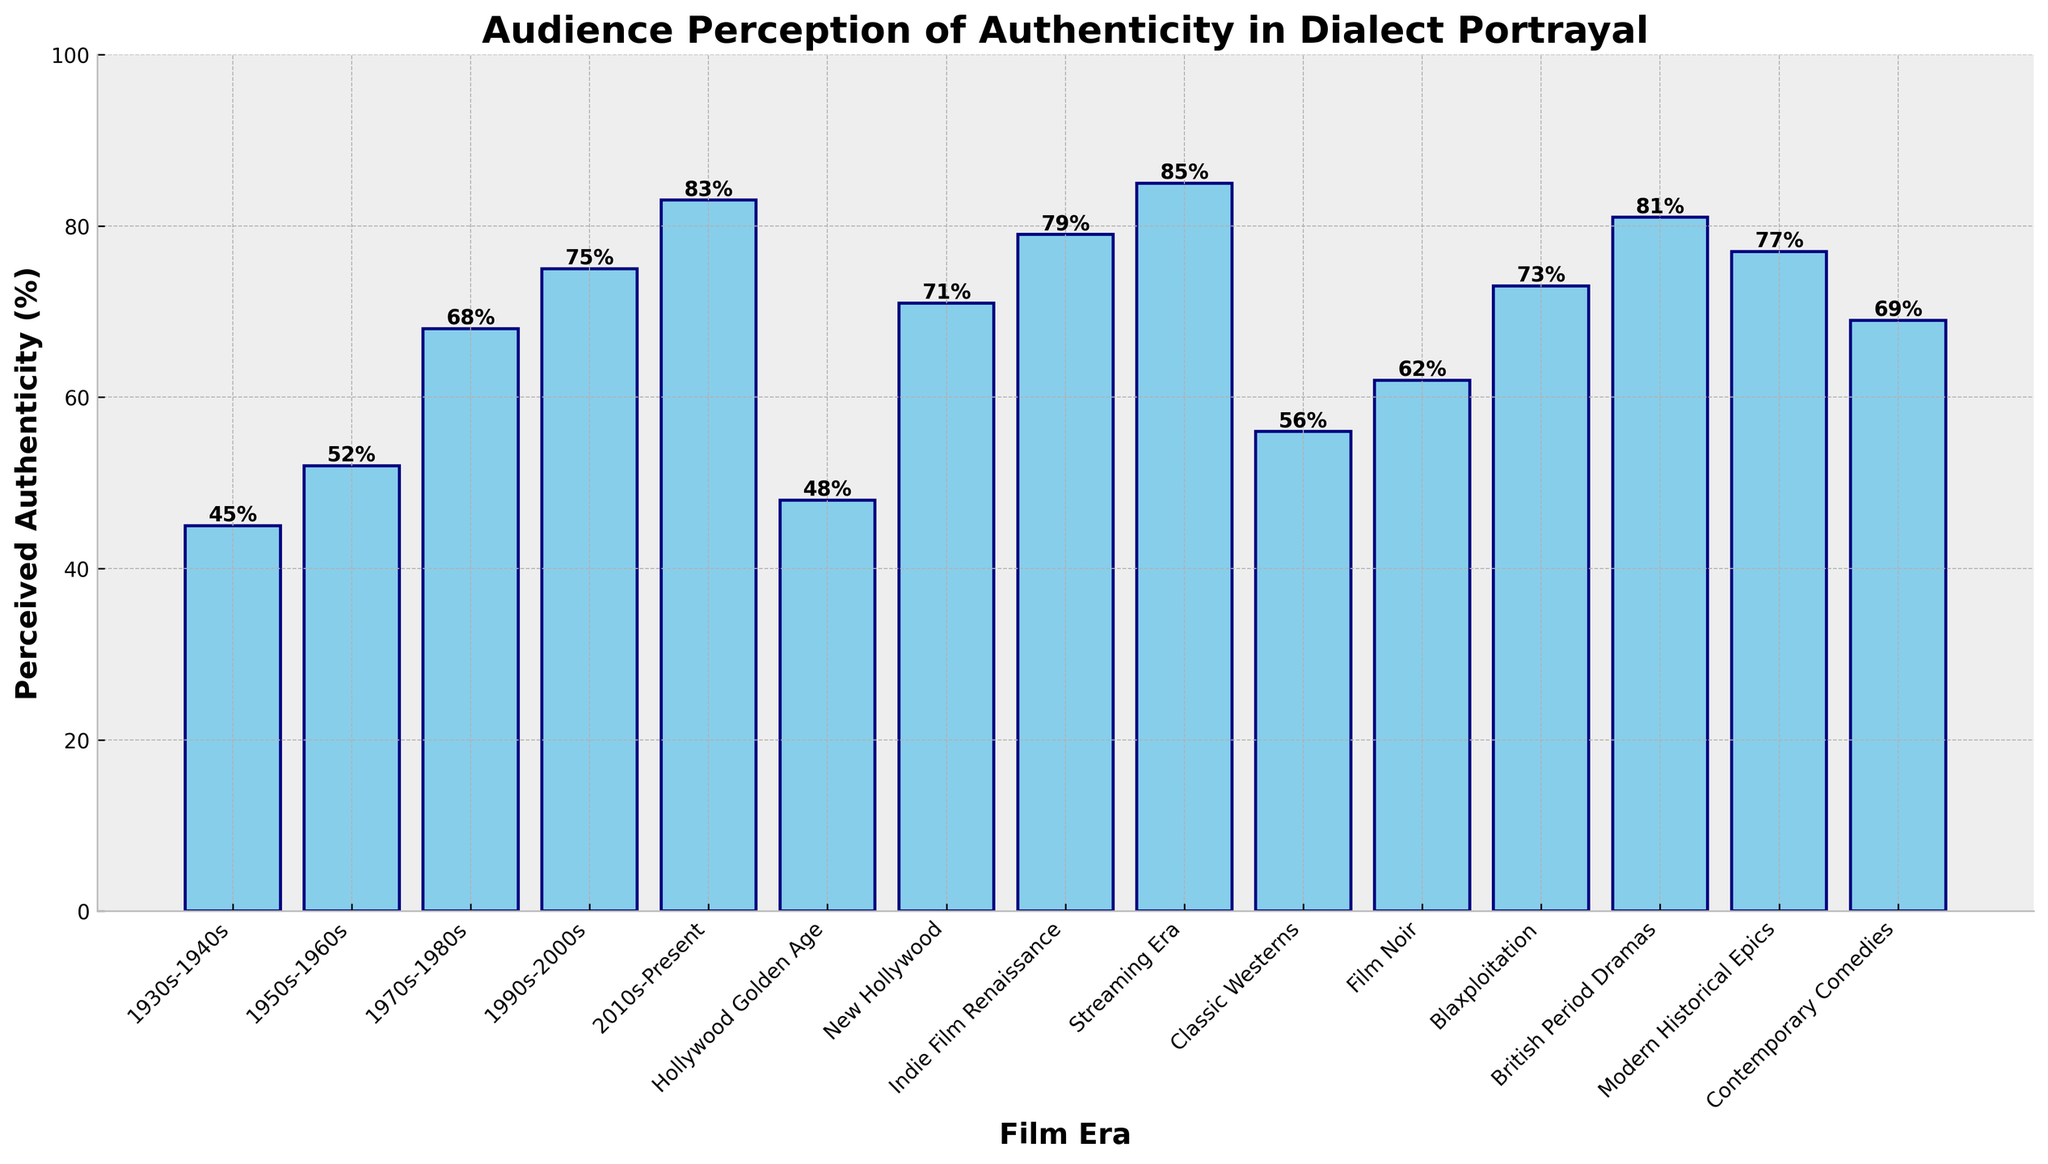Which film era has the highest perceived authenticity in dialect portrayal? Look for the bar with the greatest height to identify the film era with the highest perceived authenticity. The Streaming Era has the highest bar at 85%.
Answer: Streaming Era What is the difference in perceived authenticity between the 1930s-1940s and the 2010s-Present? Subtract the perceived authenticity percentage of the 1930s-1940s (45%) from that of the 2010s-Present (83%). The difference is 83% - 45% = 38%.
Answer: 38% Which era shows the smallest increase in perceived authenticity between two adjacent time periods? Compare the differences between adjacent time periods. The period with the smallest increase is the one where the difference is the smallest. The smallest increase is between the Hollywood Golden Age (48%) and the 1950s-1960s (52%), amounting to 52% - 48% = 4%.
Answer: Hollywood Golden Age to 1950s-1960s What is the average perceived authenticity percentage for the film eras listed? Add all the percentages and divide by the number of film eras listed. (45% + 52% + 68% + 75% + 83% + 48% + 71% + 79% + 85% + 56% + 62% + 73% + 81% + 77% + 69%) / 15 = 994% / 15 = 66.27%.
Answer: 66.27% How does the perceived authenticity of the Contemporary Comedies compare to Modern Historical Epics? Find the values of Contemporary Comedies (69%) and Modern Historical Epics (77%) and compare them. Contemporary Comedies has a lower perceived authenticity than Modern Historical Epics by 77% - 69% = 8%.
Answer: Contemporary Comedies is 8% lower than Modern Historical Epics Which film genre has nearly the same perceived authenticity as British Period Dramas? Identify the bar with a value closest to British Period Dramas (81%). The bar for Modern Historical Epics is very close at 77%.
Answer: Modern Historical Epics What is the difference in perceived authenticity between Classic Westerns and Blaxploitation genres? Subtract the perceived authenticity percentage of Classic Westerns (56%) from Blaxploitation (73%). The difference is 73% - 56% = 17%.
Answer: 17% How does the increase in perceived authenticity from New Hollywood to Indie Film Renaissance compare to the overall average increase between eras? Calculate the increase between New Hollywood (71%) and Indie Film Renaissance (79%), which is 79% - 71% = 8%. Then, find the increases between all adjacent eras, sum them, and divide by the number of intervals. (52%-48% + 68%-52% + 75%-68% + 83%-75% + 71%-48% + 79%-71% + 85%-79% + 62%-56% + 73%-62% + 81%-73% + 77%-81% + 69%-77%) / 12 = (4% + 16% + 7% + 8% + 23% + 8% + 6% + 6% + 11% + 8% - 4% - 8%) / 12 = 85% / 12 ≈ 7.08%. The increase from New Hollywood to Indie Film Renaissance is slightly higher.
Answer: Slightly higher than the overall average increase Which era shows the largest improvement in perceived authenticity from the preceding era? Determine the differences between adjacent eras, and the era with the largest positive difference has the highest improvement. The largest increase is from Hollywood Golden Age (48%) to New Hollywood (71%), amounting to 71% - 48% = 23%.
Answer: Hollywood Golden Age to New Hollywood 